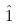<formula> <loc_0><loc_0><loc_500><loc_500>\hat { 1 }</formula> 